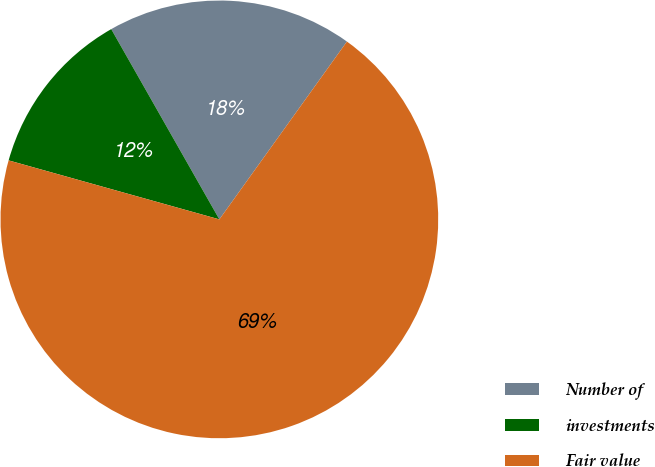Convert chart. <chart><loc_0><loc_0><loc_500><loc_500><pie_chart><fcel>Number of<fcel>investments<fcel>Fair value<nl><fcel>18.13%<fcel>12.43%<fcel>69.44%<nl></chart> 